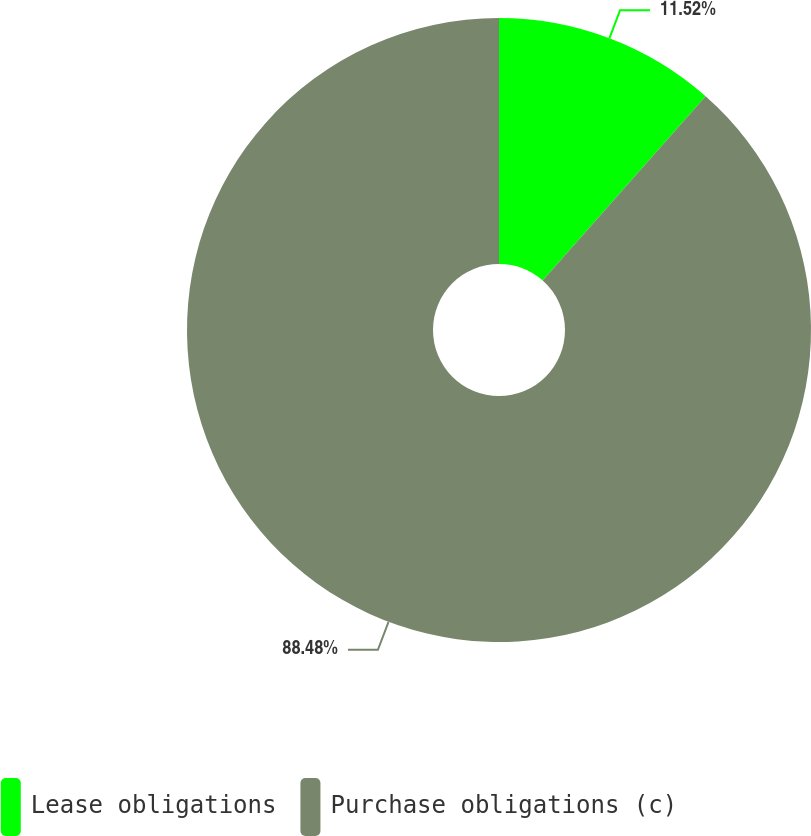<chart> <loc_0><loc_0><loc_500><loc_500><pie_chart><fcel>Lease obligations<fcel>Purchase obligations (c)<nl><fcel>11.52%<fcel>88.48%<nl></chart> 